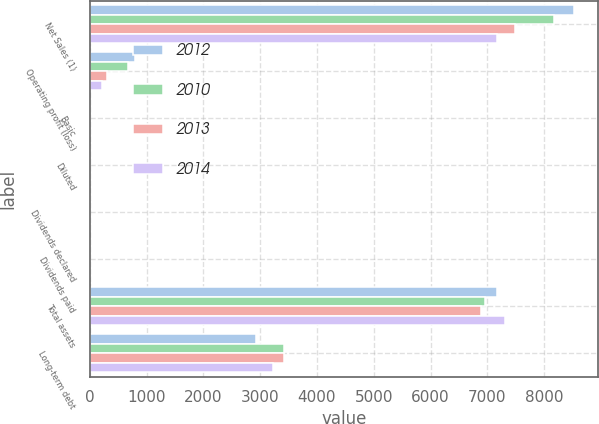Convert chart to OTSL. <chart><loc_0><loc_0><loc_500><loc_500><stacked_bar_chart><ecel><fcel>Net Sales (1)<fcel>Operating profit (loss)<fcel>Basic<fcel>Diluted<fcel>Dividends declared<fcel>Dividends paid<fcel>Total assets<fcel>Long-term debt<nl><fcel>2012<fcel>8521<fcel>788<fcel>2.42<fcel>2.39<fcel>0.34<fcel>0.33<fcel>7167<fcel>2919<nl><fcel>2010<fcel>8173<fcel>673<fcel>0.83<fcel>0.83<fcel>0.3<fcel>0.3<fcel>6957<fcel>3421<nl><fcel>2013<fcel>7495<fcel>302<fcel>0.16<fcel>0.16<fcel>0.3<fcel>0.3<fcel>6883<fcel>3422<nl><fcel>2014<fcel>7170<fcel>215<fcel>1.11<fcel>1.11<fcel>0.3<fcel>0.3<fcel>7305<fcel>3222<nl></chart> 